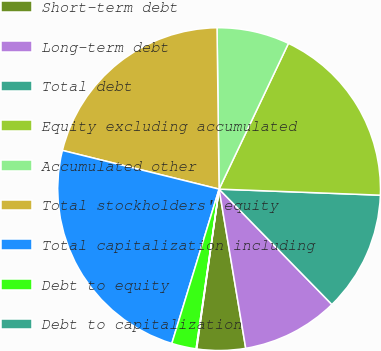Convert chart to OTSL. <chart><loc_0><loc_0><loc_500><loc_500><pie_chart><fcel>Short-term debt<fcel>Long-term debt<fcel>Total debt<fcel>Equity excluding accumulated<fcel>Accumulated other<fcel>Total stockholders' equity<fcel>Total capitalization including<fcel>Debt to equity<fcel>Debt to capitalization<nl><fcel>4.86%<fcel>9.68%<fcel>12.08%<fcel>18.53%<fcel>7.27%<fcel>20.94%<fcel>24.12%<fcel>2.46%<fcel>0.05%<nl></chart> 